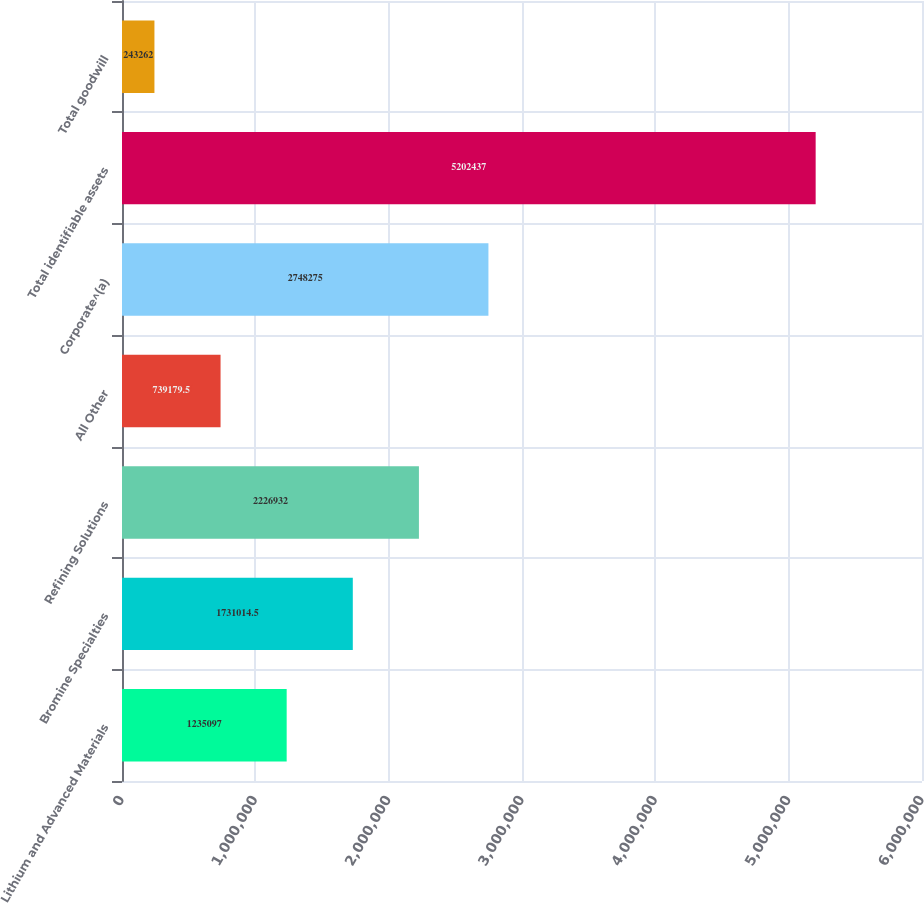<chart> <loc_0><loc_0><loc_500><loc_500><bar_chart><fcel>Lithium and Advanced Materials<fcel>Bromine Specialties<fcel>Refining Solutions<fcel>All Other<fcel>Corporate^(a)<fcel>Total identifiable assets<fcel>Total goodwill<nl><fcel>1.2351e+06<fcel>1.73101e+06<fcel>2.22693e+06<fcel>739180<fcel>2.74828e+06<fcel>5.20244e+06<fcel>243262<nl></chart> 